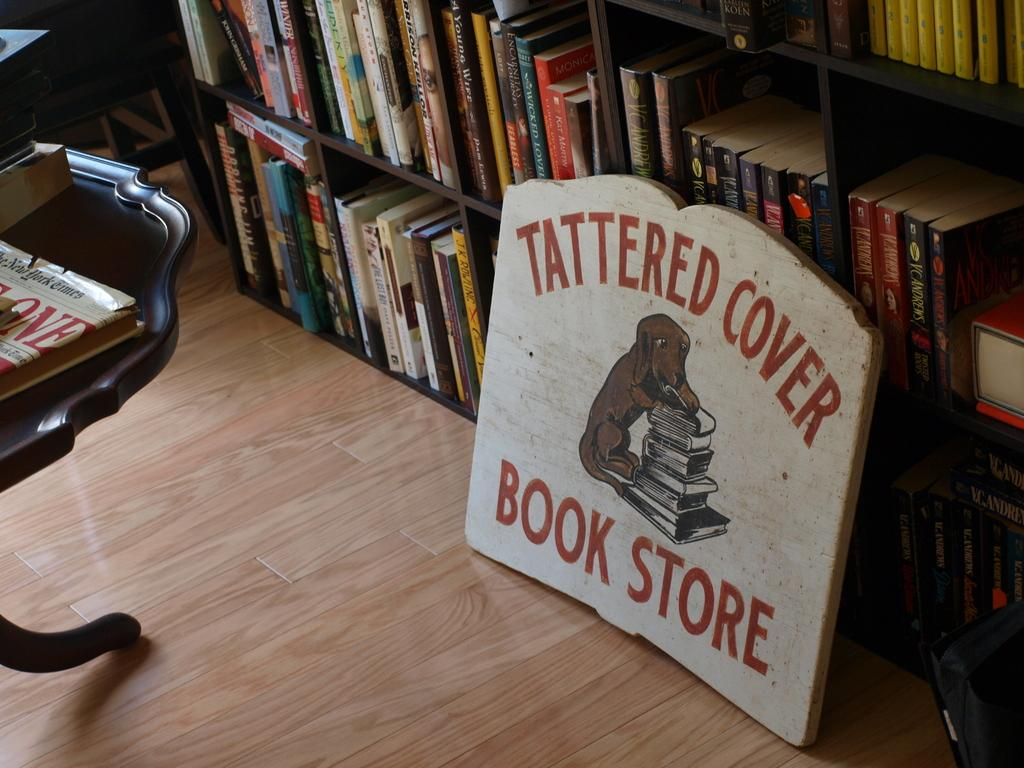<image>
Provide a brief description of the given image. the words tattered cover book store on a brown surface 